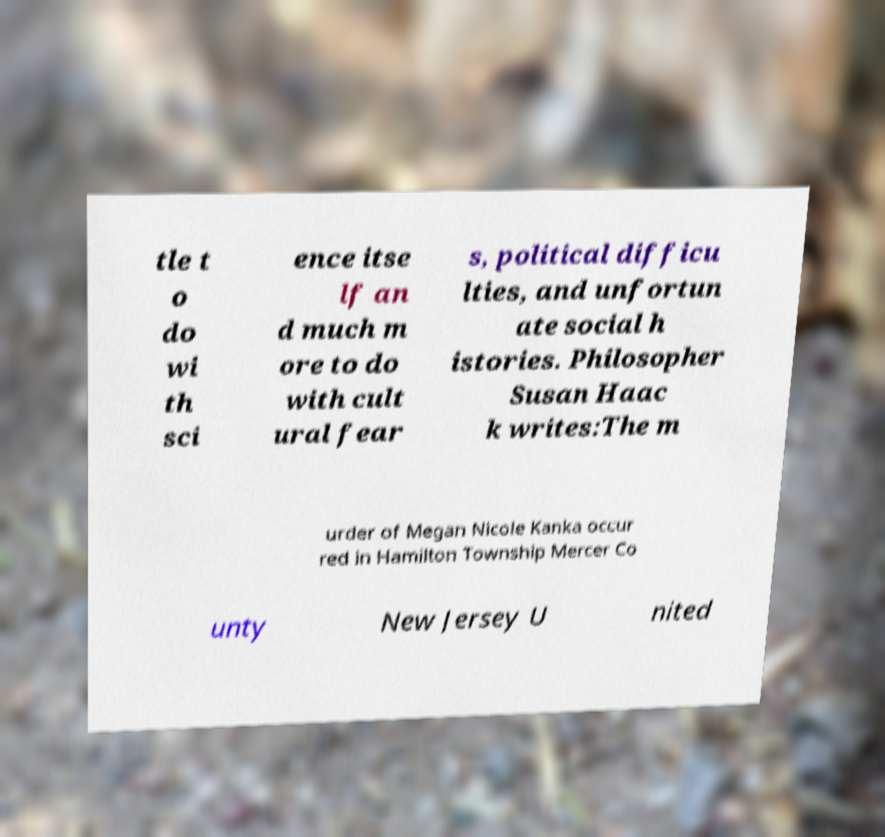Could you extract and type out the text from this image? tle t o do wi th sci ence itse lf an d much m ore to do with cult ural fear s, political difficu lties, and unfortun ate social h istories. Philosopher Susan Haac k writes:The m urder of Megan Nicole Kanka occur red in Hamilton Township Mercer Co unty New Jersey U nited 